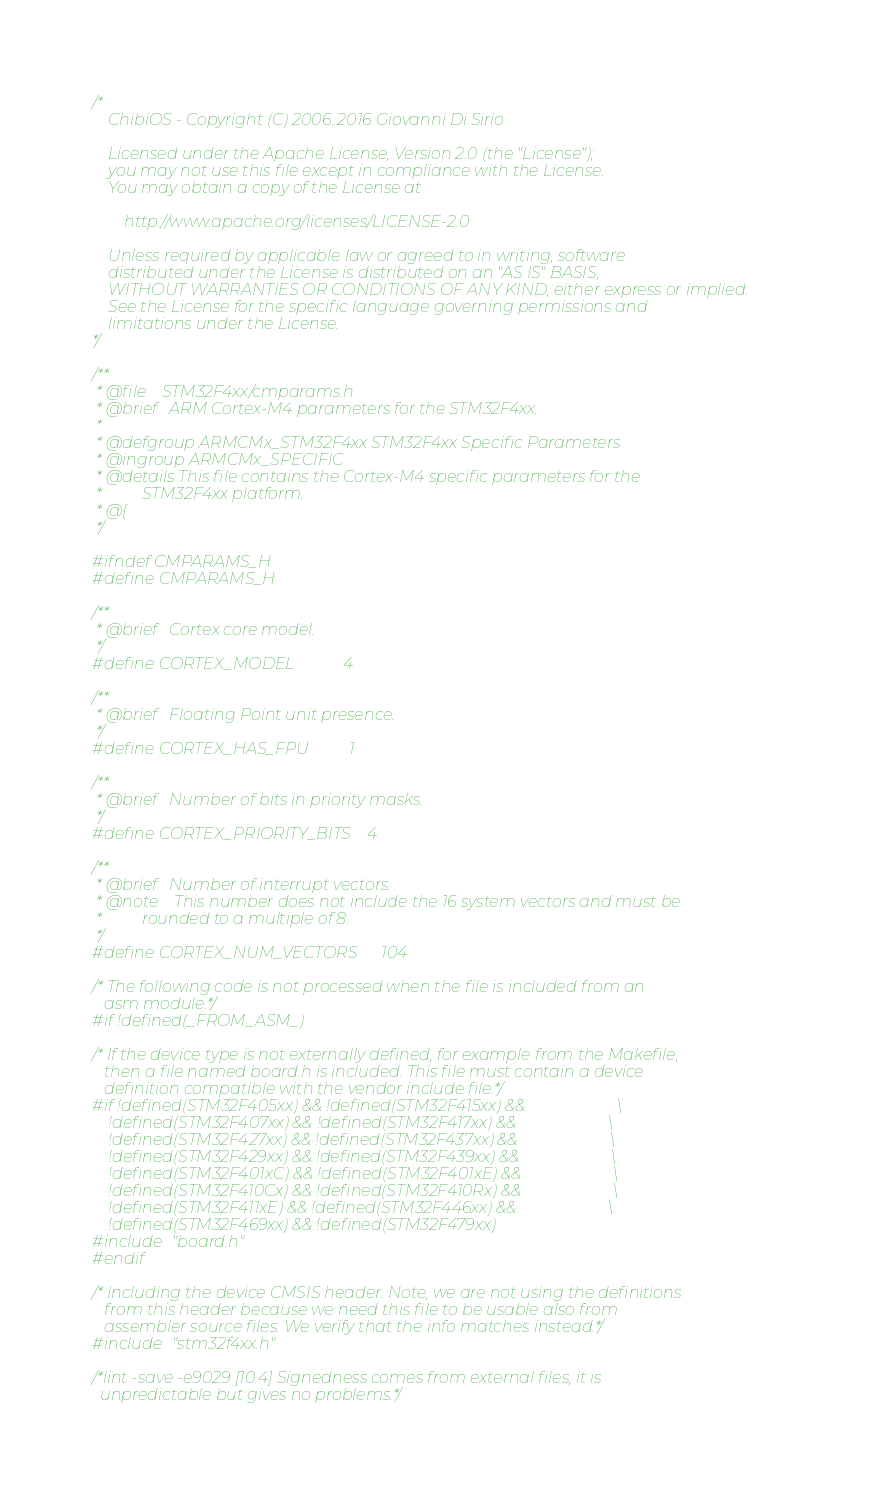Convert code to text. <code><loc_0><loc_0><loc_500><loc_500><_C_>/*
    ChibiOS - Copyright (C) 2006..2016 Giovanni Di Sirio

    Licensed under the Apache License, Version 2.0 (the "License");
    you may not use this file except in compliance with the License.
    You may obtain a copy of the License at

        http://www.apache.org/licenses/LICENSE-2.0

    Unless required by applicable law or agreed to in writing, software
    distributed under the License is distributed on an "AS IS" BASIS,
    WITHOUT WARRANTIES OR CONDITIONS OF ANY KIND, either express or implied.
    See the License for the specific language governing permissions and
    limitations under the License.
*/

/**
 * @file    STM32F4xx/cmparams.h
 * @brief   ARM Cortex-M4 parameters for the STM32F4xx.
 *
 * @defgroup ARMCMx_STM32F4xx STM32F4xx Specific Parameters
 * @ingroup ARMCMx_SPECIFIC
 * @details This file contains the Cortex-M4 specific parameters for the
 *          STM32F4xx platform.
 * @{
 */

#ifndef CMPARAMS_H
#define CMPARAMS_H

/**
 * @brief   Cortex core model.
 */
#define CORTEX_MODEL            4

/**
 * @brief   Floating Point unit presence.
 */
#define CORTEX_HAS_FPU          1

/**
 * @brief   Number of bits in priority masks.
 */
#define CORTEX_PRIORITY_BITS    4

/**
 * @brief   Number of interrupt vectors.
 * @note    This number does not include the 16 system vectors and must be
 *          rounded to a multiple of 8.
 */
#define CORTEX_NUM_VECTORS      104

/* The following code is not processed when the file is included from an
   asm module.*/
#if !defined(_FROM_ASM_)

/* If the device type is not externally defined, for example from the Makefile,
   then a file named board.h is included. This file must contain a device
   definition compatible with the vendor include file.*/
#if !defined(STM32F405xx) && !defined(STM32F415xx) &&                       \
    !defined(STM32F407xx) && !defined(STM32F417xx) &&                       \
    !defined(STM32F427xx) && !defined(STM32F437xx) &&                       \
    !defined(STM32F429xx) && !defined(STM32F439xx) &&                       \
    !defined(STM32F401xC) && !defined(STM32F401xE) &&                       \
    !defined(STM32F410Cx) && !defined(STM32F410Rx) &&                       \
    !defined(STM32F411xE) && !defined(STM32F446xx) &&                       \
    !defined(STM32F469xx) && !defined(STM32F479xx)
#include "board.h"
#endif

/* Including the device CMSIS header. Note, we are not using the definitions
   from this header because we need this file to be usable also from
   assembler source files. We verify that the info matches instead.*/
#include "stm32f4xx.h"

/*lint -save -e9029 [10.4] Signedness comes from external files, it is
  unpredictable but gives no problems.*/</code> 